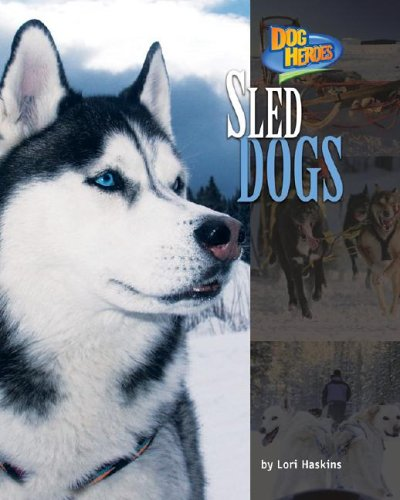Is this a games-related book? While not a game in the conventional sense, this book covers the sport and teamwork involved in sled dog racing, a competitive and historically significant activity. 